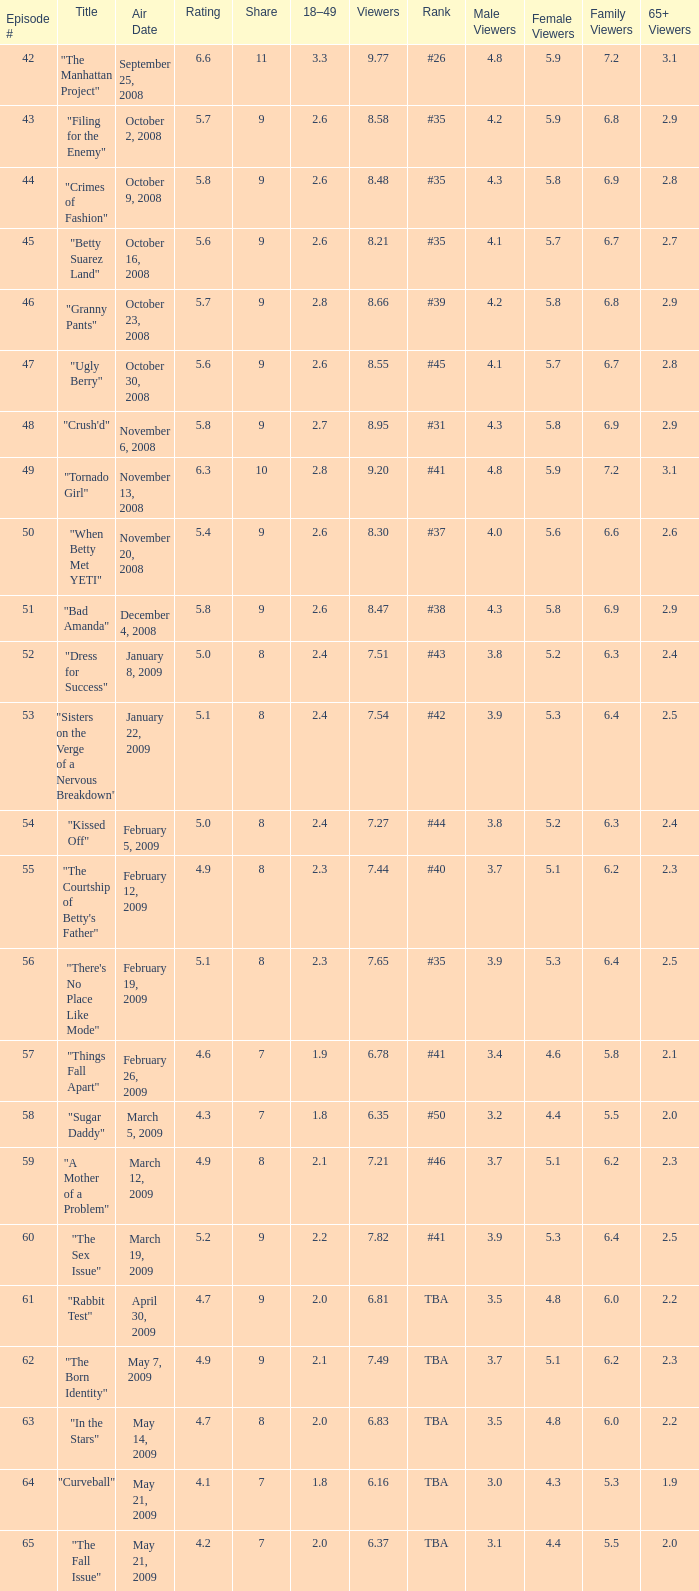What is the average Episode # with a share of 9, and #35 is rank and less than 8.21 viewers? None. 